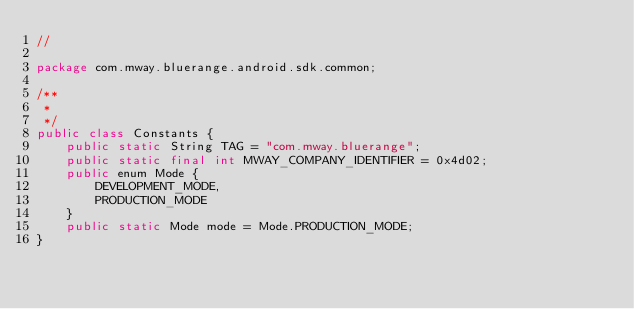Convert code to text. <code><loc_0><loc_0><loc_500><loc_500><_Java_>//

package com.mway.bluerange.android.sdk.common;

/**
 *
 */
public class Constants {
    public static String TAG = "com.mway.bluerange";
    public static final int MWAY_COMPANY_IDENTIFIER = 0x4d02;
    public enum Mode {
        DEVELOPMENT_MODE,
        PRODUCTION_MODE
    }
    public static Mode mode = Mode.PRODUCTION_MODE;
}
</code> 